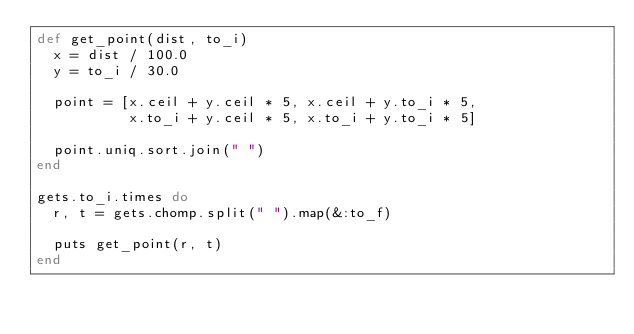<code> <loc_0><loc_0><loc_500><loc_500><_Ruby_>def get_point(dist, to_i)
  x = dist / 100.0
  y = to_i / 30.0
  
  point = [x.ceil + y.ceil * 5, x.ceil + y.to_i * 5,
           x.to_i + y.ceil * 5, x.to_i + y.to_i * 5]
 
  point.uniq.sort.join(" ")
end

gets.to_i.times do
  r, t = gets.chomp.split(" ").map(&:to_f)
  
  puts get_point(r, t)
end</code> 